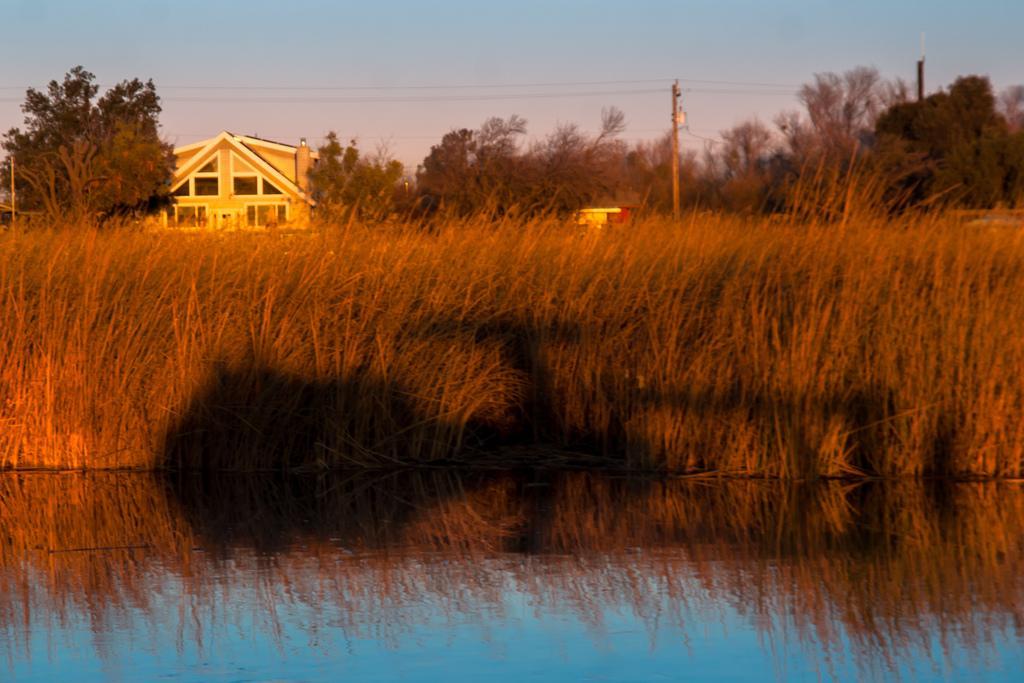Could you give a brief overview of what you see in this image? In this picture I can see a building and few trees and plants in the water and I can see poles and a blue cloudy sky. 